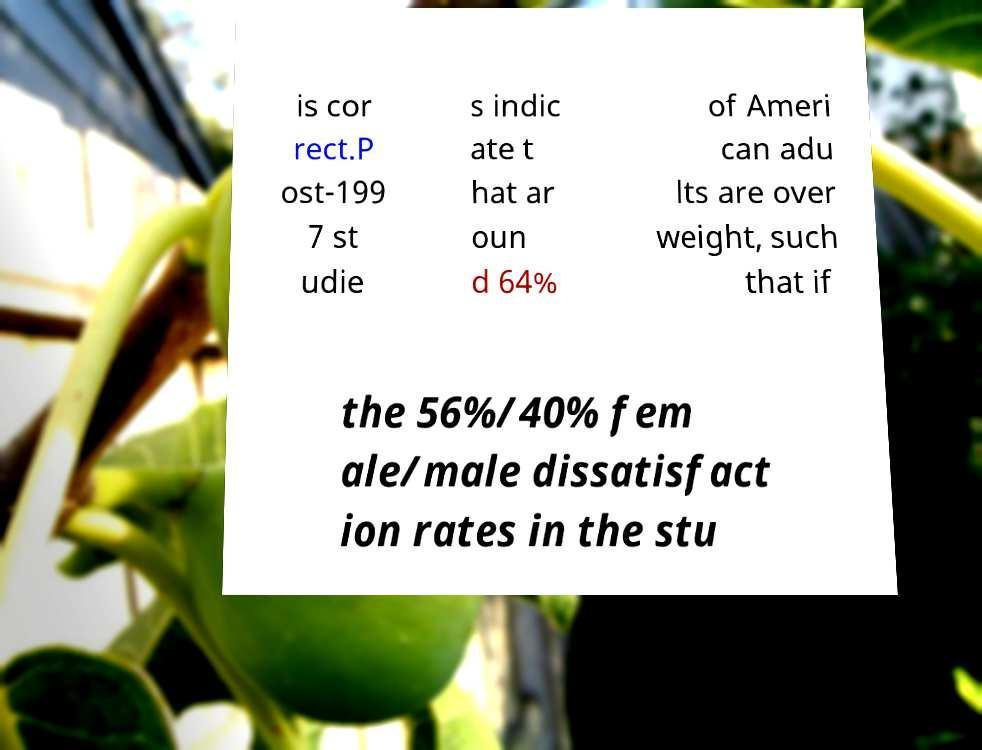For documentation purposes, I need the text within this image transcribed. Could you provide that? is cor rect.P ost-199 7 st udie s indic ate t hat ar oun d 64% of Ameri can adu lts are over weight, such that if the 56%/40% fem ale/male dissatisfact ion rates in the stu 